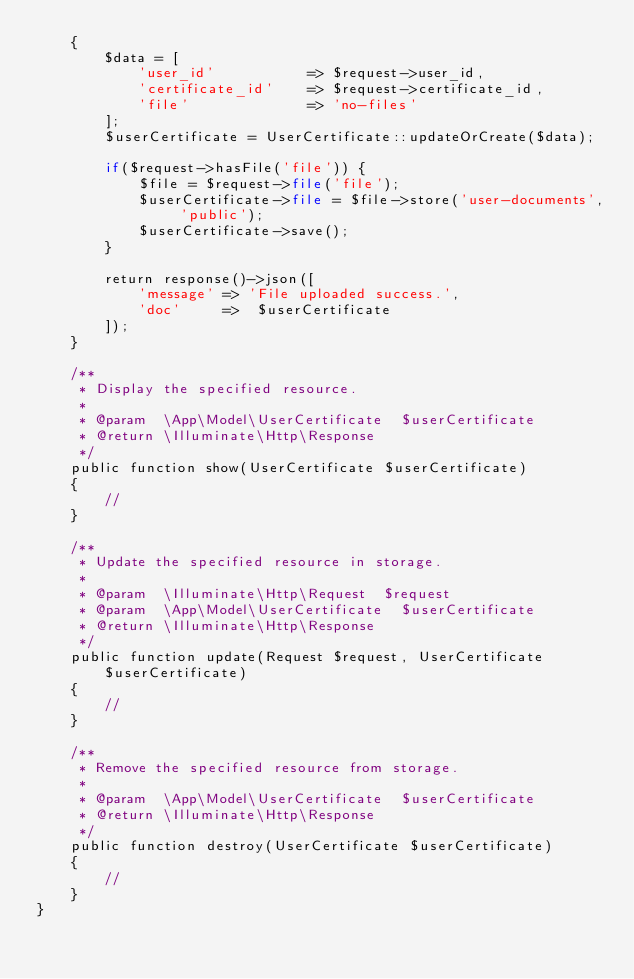<code> <loc_0><loc_0><loc_500><loc_500><_PHP_>    {
        $data = [
            'user_id'           => $request->user_id,
            'certificate_id'    => $request->certificate_id,
            'file'              => 'no-files'
        ];
        $userCertificate = UserCertificate::updateOrCreate($data);

        if($request->hasFile('file')) {
            $file = $request->file('file');
            $userCertificate->file = $file->store('user-documents', 'public');
            $userCertificate->save();
        }

        return response()->json([
            'message' => 'File uploaded success.',
            'doc'     =>  $userCertificate
        ]);
    }

    /**
     * Display the specified resource.
     *
     * @param  \App\Model\UserCertificate  $userCertificate
     * @return \Illuminate\Http\Response
     */
    public function show(UserCertificate $userCertificate)
    {
        //
    }

    /**
     * Update the specified resource in storage.
     *
     * @param  \Illuminate\Http\Request  $request
     * @param  \App\Model\UserCertificate  $userCertificate
     * @return \Illuminate\Http\Response
     */
    public function update(Request $request, UserCertificate $userCertificate)
    {
        //
    }

    /**
     * Remove the specified resource from storage.
     *
     * @param  \App\Model\UserCertificate  $userCertificate
     * @return \Illuminate\Http\Response
     */
    public function destroy(UserCertificate $userCertificate)
    {
        //
    }
}
</code> 